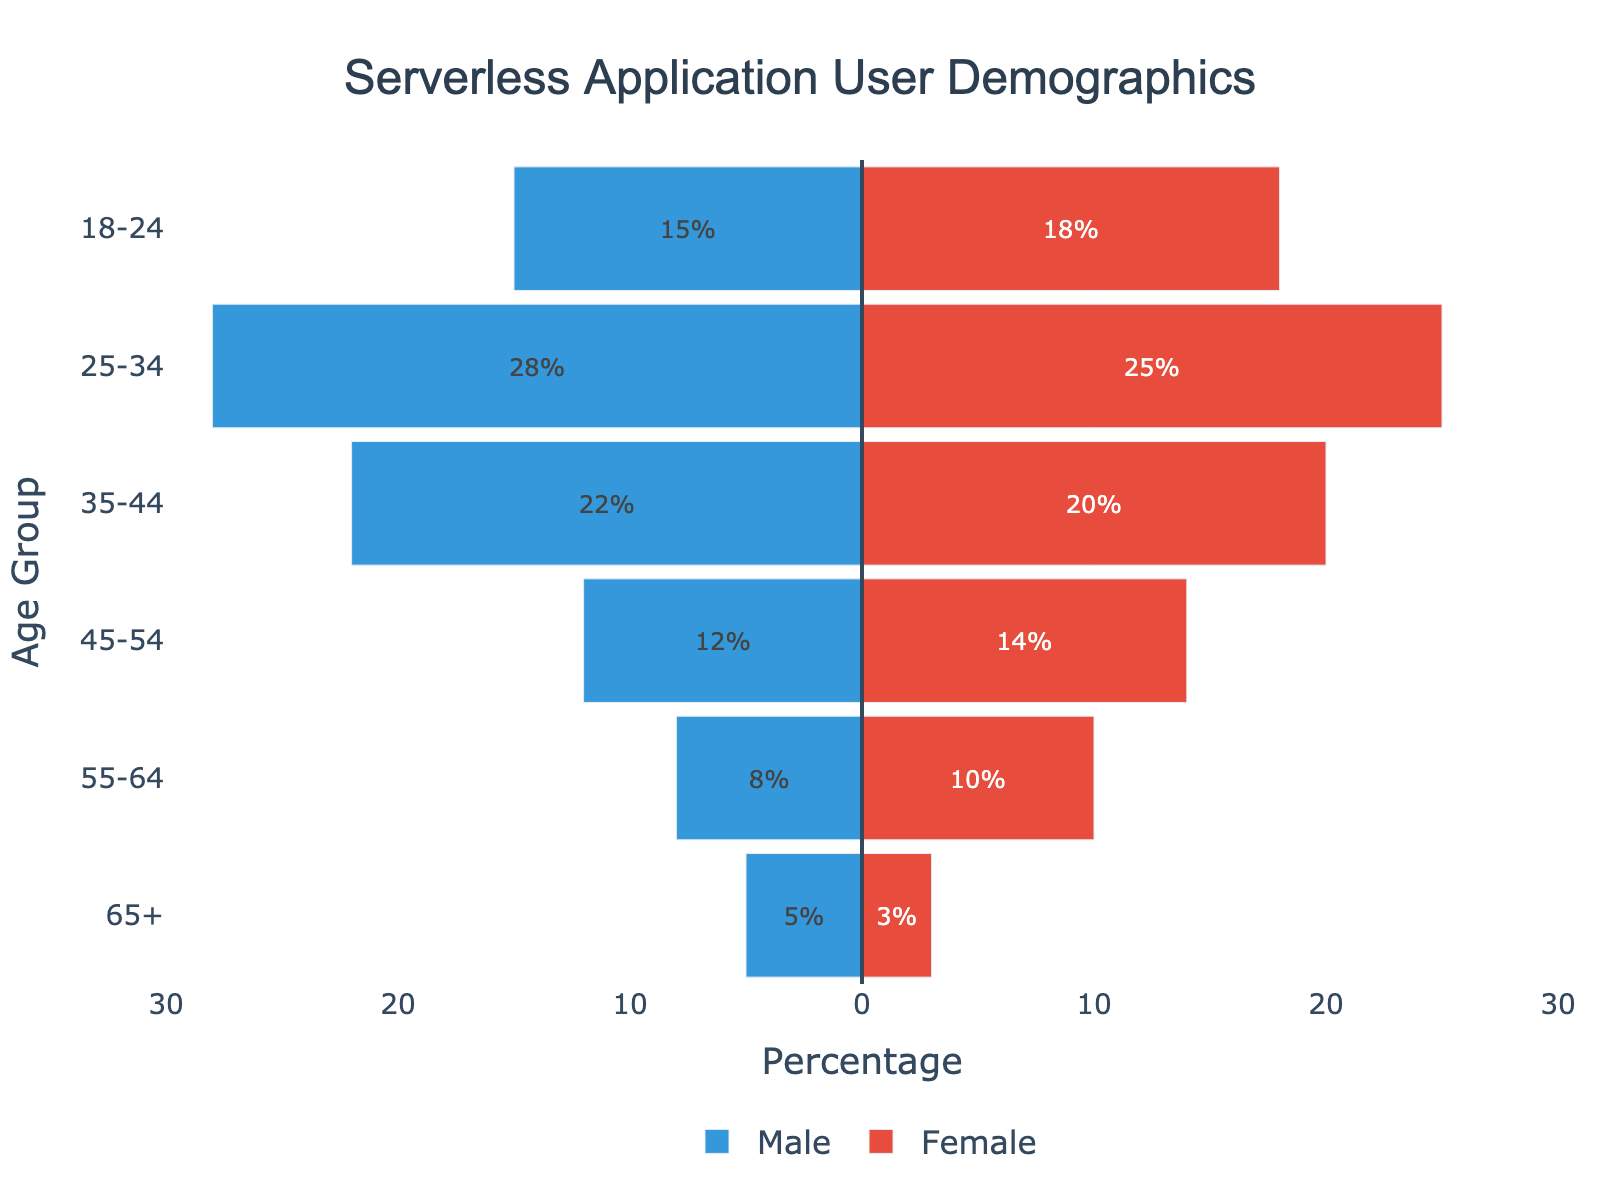What's the largest age group for male users? The largest age group for male users is the one with the highest absolute value of the negative bar. In this case, it's the 25-34 age group with a value of 28.
Answer: 25-34 Which gender has more users in the 45-54 age group? By comparing the lengths of the bars for males and females in the 45-54 age group, we see that the female bar is longer with a value of 14, compared to 12 for males.
Answer: Female What is the total number of users in the 18-24 age group? Summing the male and female values in the 18-24 age group, we get 15 (male) + 18 (female) = 33.
Answer: 33 Which age group has the smallest number of users for female? The smallest number for female users can be found by identifying the shortest positive bar. This is the 65+ age group with a value of 3.
Answer: 65+ How many more users are in the 35-44 age group compared to the 55-64 age group for males? Subtracting the male value in the 55-64 age group (8) from the 35-44 age group (22), we get 22 - 8 = 14.
Answer: 14 What is the combined number of users in the 25-34 and 35-44 age groups for females? Adding the female values for the 25-34 age group (25) and the 35-44 age group (20), we get 25 + 20 = 45.
Answer: 45 Which age group shows a more balanced gender distribution? Comparing the absolute differences between male and female counts for each age group: 18-24 is 3, 25-34 is 3, 35-44 is 2, 45-54 is 2, 55-64 is 2, and 65+ is 2. The smallest difference is shown by the 35-44, 45-54, 55-64, and 65+ age groups with a difference of 2.
Answer: 35-44, 45-54, 55-64, 65+ What age group has the highest percentage of users if you combine both male and female counts? Summing male and female counts per age group, the 25-34 age group has the highest total with 28 (male) + 25 (female) = 53.
Answer: 25-34 Is the male user base younger or older on average compared to the female user base? Calculate the weighted average age for both genders. For males: (15*21) + (28*29.5) + (22*39.5) + (12*49.5) + (8*59.5) + (5*70) / (15+28+22+12+8+5). Similarly for females: (18*21) + (25*29.5) + (20*39.5) + (14*49.5) + (10*59.5) + (3*70) / (18+25+20+14+10+3). Males have a weighted average of approximately 34.9; females, 34.2. Therefore, the female user base is younger on average.
Answer: Female 